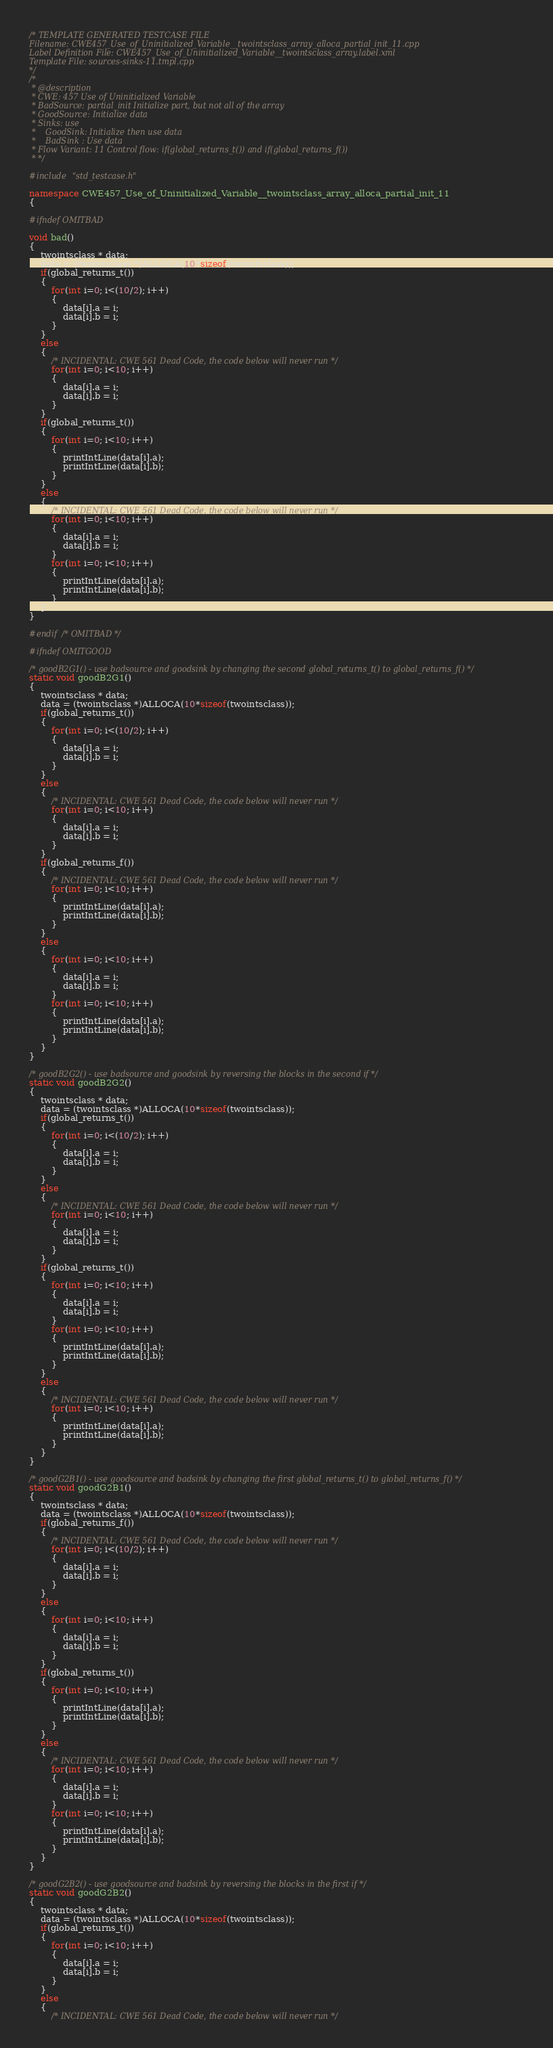<code> <loc_0><loc_0><loc_500><loc_500><_C++_>/* TEMPLATE GENERATED TESTCASE FILE
Filename: CWE457_Use_of_Uninitialized_Variable__twointsclass_array_alloca_partial_init_11.cpp
Label Definition File: CWE457_Use_of_Uninitialized_Variable__twointsclass_array.label.xml
Template File: sources-sinks-11.tmpl.cpp
*/
/*
 * @description
 * CWE: 457 Use of Uninitialized Variable
 * BadSource: partial_init Initialize part, but not all of the array
 * GoodSource: Initialize data
 * Sinks: use
 *    GoodSink: Initialize then use data
 *    BadSink : Use data
 * Flow Variant: 11 Control flow: if(global_returns_t()) and if(global_returns_f())
 * */

#include "std_testcase.h"

namespace CWE457_Use_of_Uninitialized_Variable__twointsclass_array_alloca_partial_init_11
{

#ifndef OMITBAD

void bad()
{
    twointsclass * data;
    data = (twointsclass *)ALLOCA(10*sizeof(twointsclass));
    if(global_returns_t())
    {
        for(int i=0; i<(10/2); i++)
        {
            data[i].a = i;
            data[i].b = i;
        }
    }
    else
    {
        /* INCIDENTAL: CWE 561 Dead Code, the code below will never run */
        for(int i=0; i<10; i++)
        {
            data[i].a = i;
            data[i].b = i;
        }
    }
    if(global_returns_t())
    {
        for(int i=0; i<10; i++)
        {
            printIntLine(data[i].a);
            printIntLine(data[i].b);
        }
    }
    else
    {
        /* INCIDENTAL: CWE 561 Dead Code, the code below will never run */
        for(int i=0; i<10; i++)
        {
            data[i].a = i;
            data[i].b = i;
        }
        for(int i=0; i<10; i++)
        {
            printIntLine(data[i].a);
            printIntLine(data[i].b);
        }
    }
}

#endif /* OMITBAD */

#ifndef OMITGOOD

/* goodB2G1() - use badsource and goodsink by changing the second global_returns_t() to global_returns_f() */
static void goodB2G1()
{
    twointsclass * data;
    data = (twointsclass *)ALLOCA(10*sizeof(twointsclass));
    if(global_returns_t())
    {
        for(int i=0; i<(10/2); i++)
        {
            data[i].a = i;
            data[i].b = i;
        }
    }
    else
    {
        /* INCIDENTAL: CWE 561 Dead Code, the code below will never run */
        for(int i=0; i<10; i++)
        {
            data[i].a = i;
            data[i].b = i;
        }
    }
    if(global_returns_f())
    {
        /* INCIDENTAL: CWE 561 Dead Code, the code below will never run */
        for(int i=0; i<10; i++)
        {
            printIntLine(data[i].a);
            printIntLine(data[i].b);
        }
    }
    else
    {
        for(int i=0; i<10; i++)
        {
            data[i].a = i;
            data[i].b = i;
        }
        for(int i=0; i<10; i++)
        {
            printIntLine(data[i].a);
            printIntLine(data[i].b);
        }
    }
}

/* goodB2G2() - use badsource and goodsink by reversing the blocks in the second if */
static void goodB2G2()
{
    twointsclass * data;
    data = (twointsclass *)ALLOCA(10*sizeof(twointsclass));
    if(global_returns_t())
    {
        for(int i=0; i<(10/2); i++)
        {
            data[i].a = i;
            data[i].b = i;
        }
    }
    else
    {
        /* INCIDENTAL: CWE 561 Dead Code, the code below will never run */
        for(int i=0; i<10; i++)
        {
            data[i].a = i;
            data[i].b = i;
        }
    }
    if(global_returns_t())
    {
        for(int i=0; i<10; i++)
        {
            data[i].a = i;
            data[i].b = i;
        }
        for(int i=0; i<10; i++)
        {
            printIntLine(data[i].a);
            printIntLine(data[i].b);
        }
    }
    else
    {
        /* INCIDENTAL: CWE 561 Dead Code, the code below will never run */
        for(int i=0; i<10; i++)
        {
            printIntLine(data[i].a);
            printIntLine(data[i].b);
        }
    }
}

/* goodG2B1() - use goodsource and badsink by changing the first global_returns_t() to global_returns_f() */
static void goodG2B1()
{
    twointsclass * data;
    data = (twointsclass *)ALLOCA(10*sizeof(twointsclass));
    if(global_returns_f())
    {
        /* INCIDENTAL: CWE 561 Dead Code, the code below will never run */
        for(int i=0; i<(10/2); i++)
        {
            data[i].a = i;
            data[i].b = i;
        }
    }
    else
    {
        for(int i=0; i<10; i++)
        {
            data[i].a = i;
            data[i].b = i;
        }
    }
    if(global_returns_t())
    {
        for(int i=0; i<10; i++)
        {
            printIntLine(data[i].a);
            printIntLine(data[i].b);
        }
    }
    else
    {
        /* INCIDENTAL: CWE 561 Dead Code, the code below will never run */
        for(int i=0; i<10; i++)
        {
            data[i].a = i;
            data[i].b = i;
        }
        for(int i=0; i<10; i++)
        {
            printIntLine(data[i].a);
            printIntLine(data[i].b);
        }
    }
}

/* goodG2B2() - use goodsource and badsink by reversing the blocks in the first if */
static void goodG2B2()
{
    twointsclass * data;
    data = (twointsclass *)ALLOCA(10*sizeof(twointsclass));
    if(global_returns_t())
    {
        for(int i=0; i<10; i++)
        {
            data[i].a = i;
            data[i].b = i;
        }
    }
    else
    {
        /* INCIDENTAL: CWE 561 Dead Code, the code below will never run */</code> 